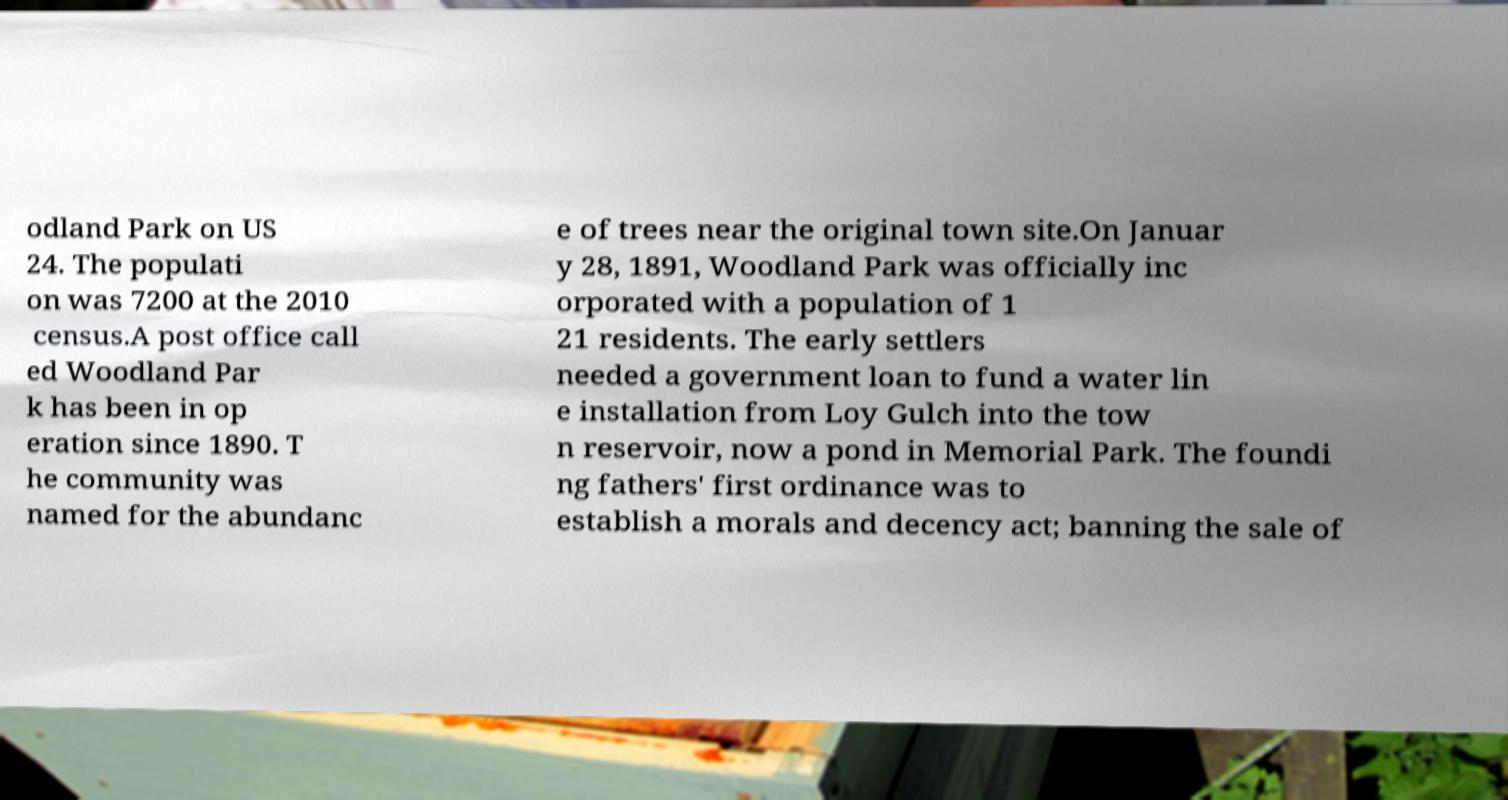Can you read and provide the text displayed in the image?This photo seems to have some interesting text. Can you extract and type it out for me? odland Park on US 24. The populati on was 7200 at the 2010 census.A post office call ed Woodland Par k has been in op eration since 1890. T he community was named for the abundanc e of trees near the original town site.On Januar y 28, 1891, Woodland Park was officially inc orporated with a population of 1 21 residents. The early settlers needed a government loan to fund a water lin e installation from Loy Gulch into the tow n reservoir, now a pond in Memorial Park. The foundi ng fathers' first ordinance was to establish a morals and decency act; banning the sale of 